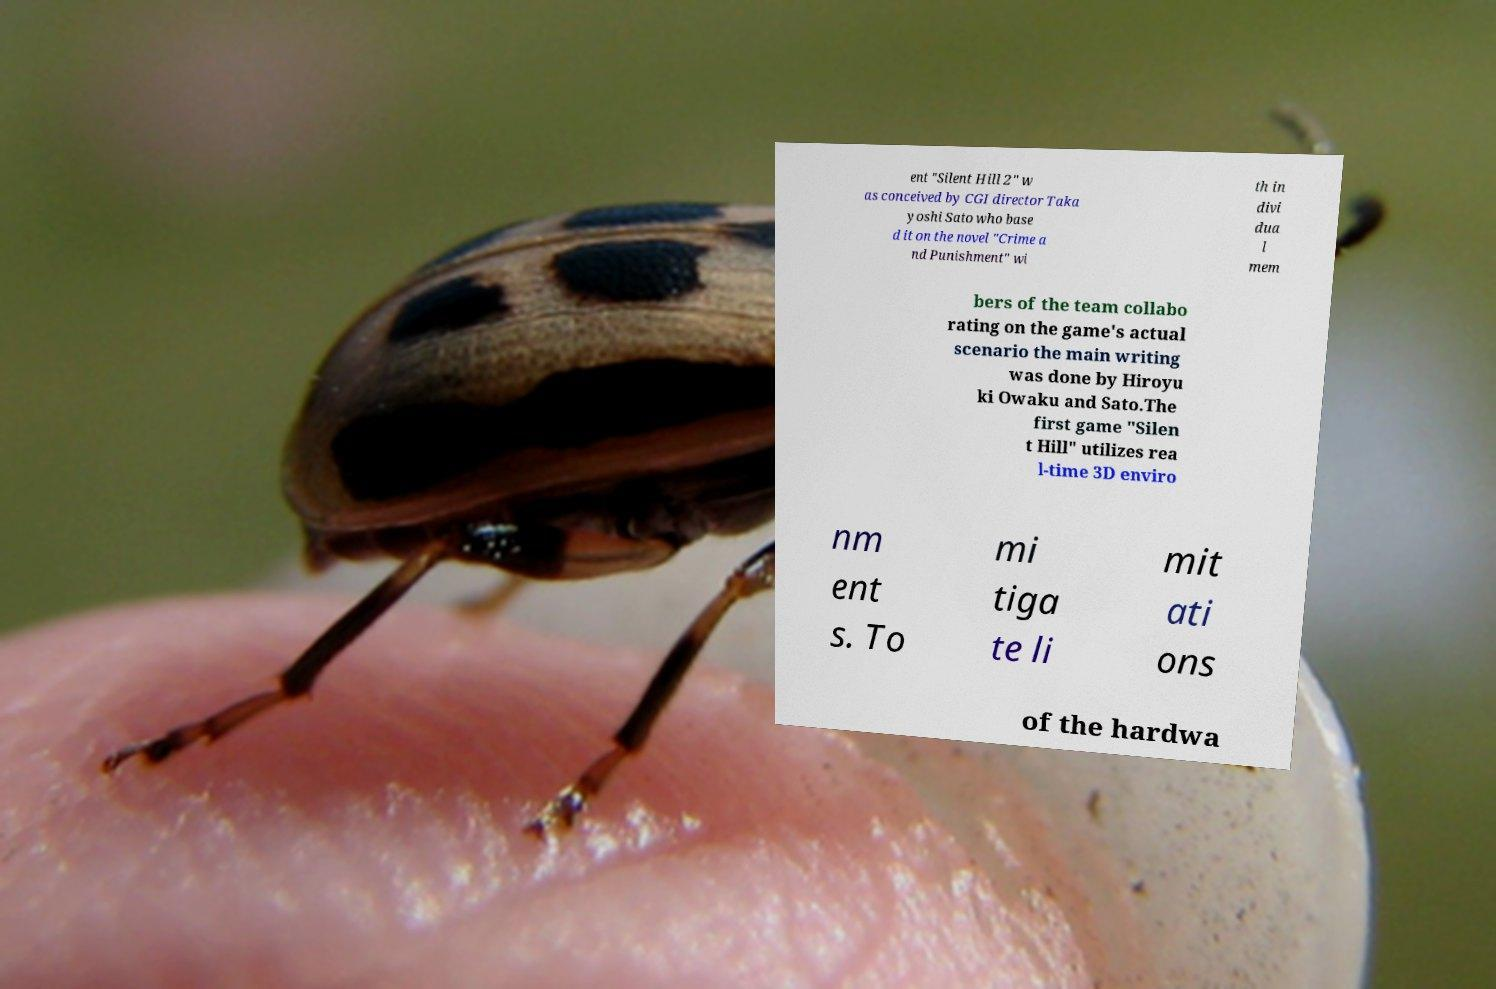Please read and relay the text visible in this image. What does it say? ent "Silent Hill 2" w as conceived by CGI director Taka yoshi Sato who base d it on the novel "Crime a nd Punishment" wi th in divi dua l mem bers of the team collabo rating on the game's actual scenario the main writing was done by Hiroyu ki Owaku and Sato.The first game "Silen t Hill" utilizes rea l-time 3D enviro nm ent s. To mi tiga te li mit ati ons of the hardwa 